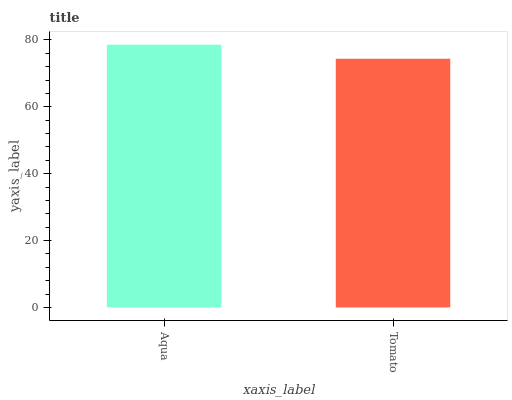Is Tomato the minimum?
Answer yes or no. Yes. Is Aqua the maximum?
Answer yes or no. Yes. Is Tomato the maximum?
Answer yes or no. No. Is Aqua greater than Tomato?
Answer yes or no. Yes. Is Tomato less than Aqua?
Answer yes or no. Yes. Is Tomato greater than Aqua?
Answer yes or no. No. Is Aqua less than Tomato?
Answer yes or no. No. Is Aqua the high median?
Answer yes or no. Yes. Is Tomato the low median?
Answer yes or no. Yes. Is Tomato the high median?
Answer yes or no. No. Is Aqua the low median?
Answer yes or no. No. 